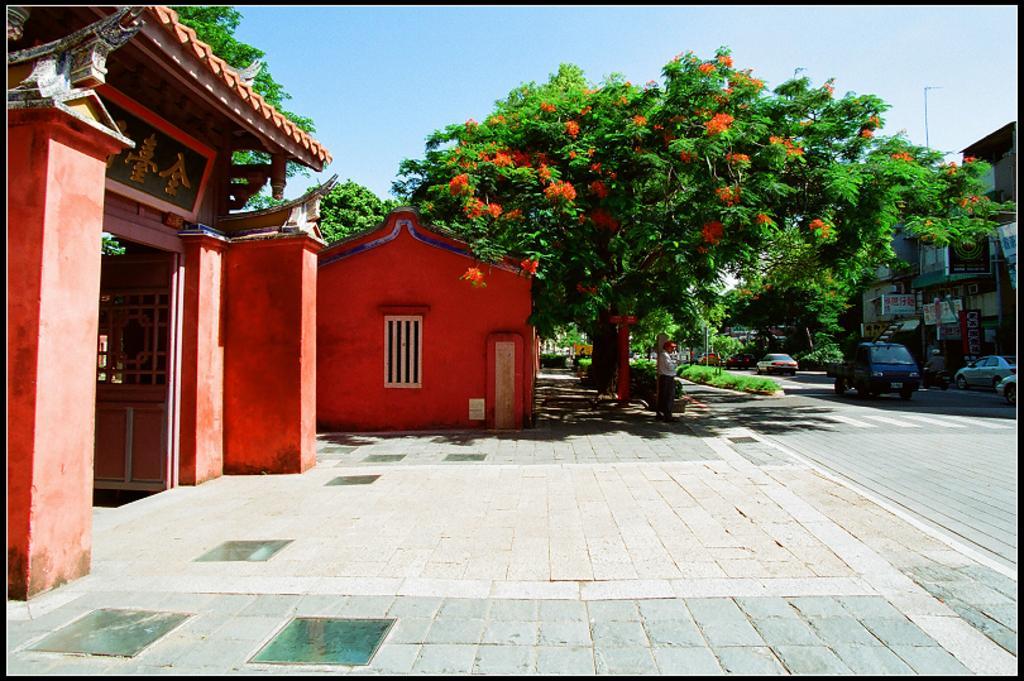How would you summarize this image in a sentence or two? In this image I can see the ground, the road, few vehicles on the road, a person standing, few trees, few orange colored flowers, an arch and few buildings. In the background I can see the sky. 